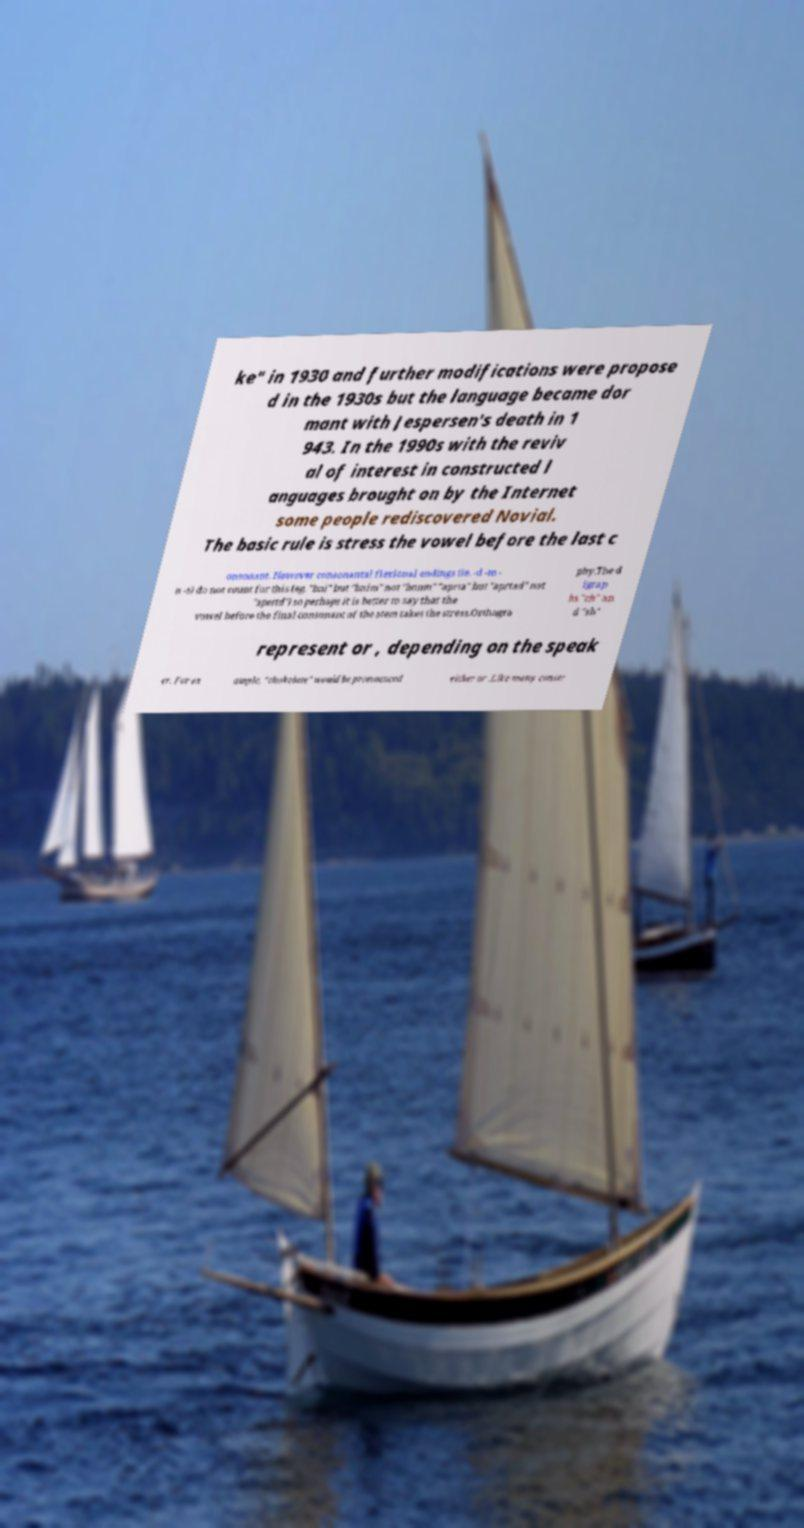Please read and relay the text visible in this image. What does it say? ke" in 1930 and further modifications were propose d in the 1930s but the language became dor mant with Jespersen's death in 1 943. In the 1990s with the reviv al of interest in constructed l anguages brought on by the Internet some people rediscovered Novial. The basic rule is stress the vowel before the last c onsonant. However consonantal flexional endings (ie. -d -m - n -s) do not count for this (eg. "bni" but "bnim" not "bonm" "aprta" but "aprtad" not "apertd") so perhaps it is better to say that the vowel before the final consonant of the stem takes the stress.Orthogra phy.The d igrap hs "ch" an d "sh" represent or , depending on the speak er. For ex ample, "chokolate" would be pronounced either or .Like many constr 